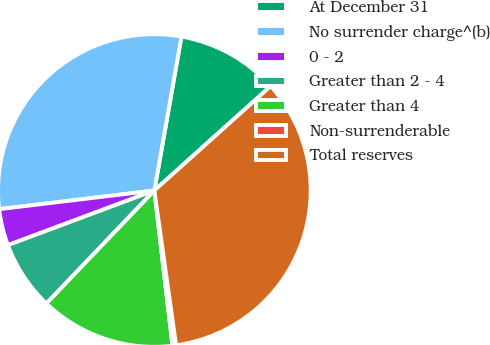Convert chart. <chart><loc_0><loc_0><loc_500><loc_500><pie_chart><fcel>At December 31<fcel>No surrender charge^(b)<fcel>0 - 2<fcel>Greater than 2 - 4<fcel>Greater than 4<fcel>Non-surrenderable<fcel>Total reserves<nl><fcel>10.59%<fcel>29.68%<fcel>3.78%<fcel>7.18%<fcel>13.99%<fcel>0.37%<fcel>34.42%<nl></chart> 